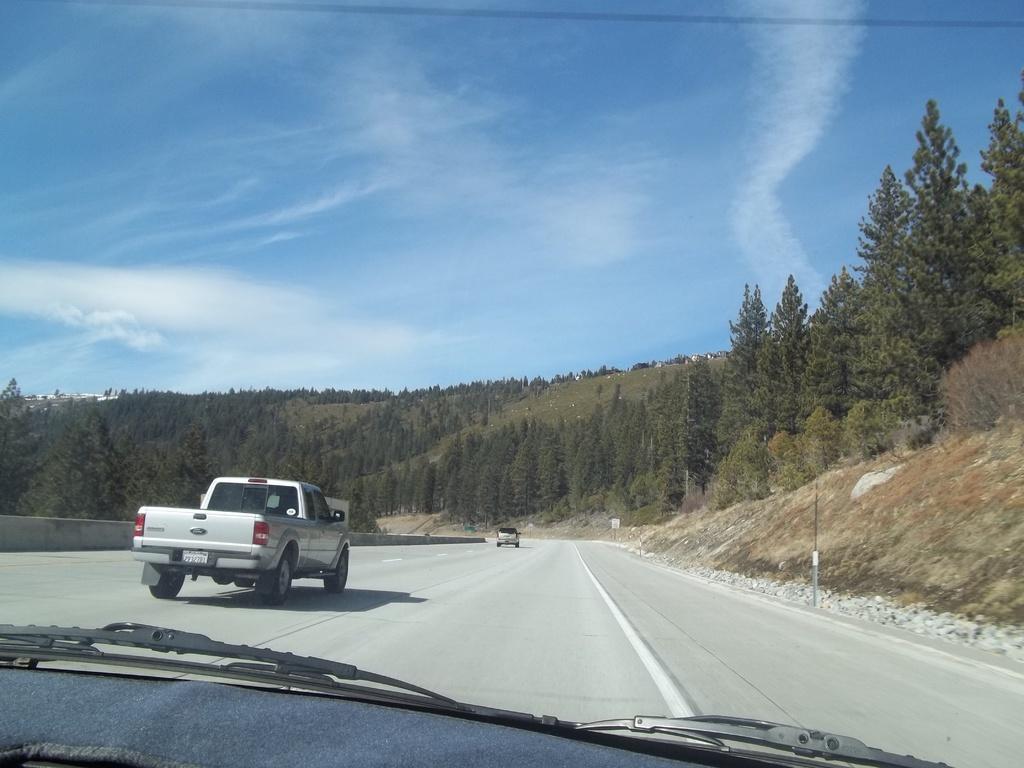How would you summarize this image in a sentence or two? This is the picture of a vehicle mirror from which we can see two other vehicles on the road and around there are some mountains on which there are some trees and plants. 